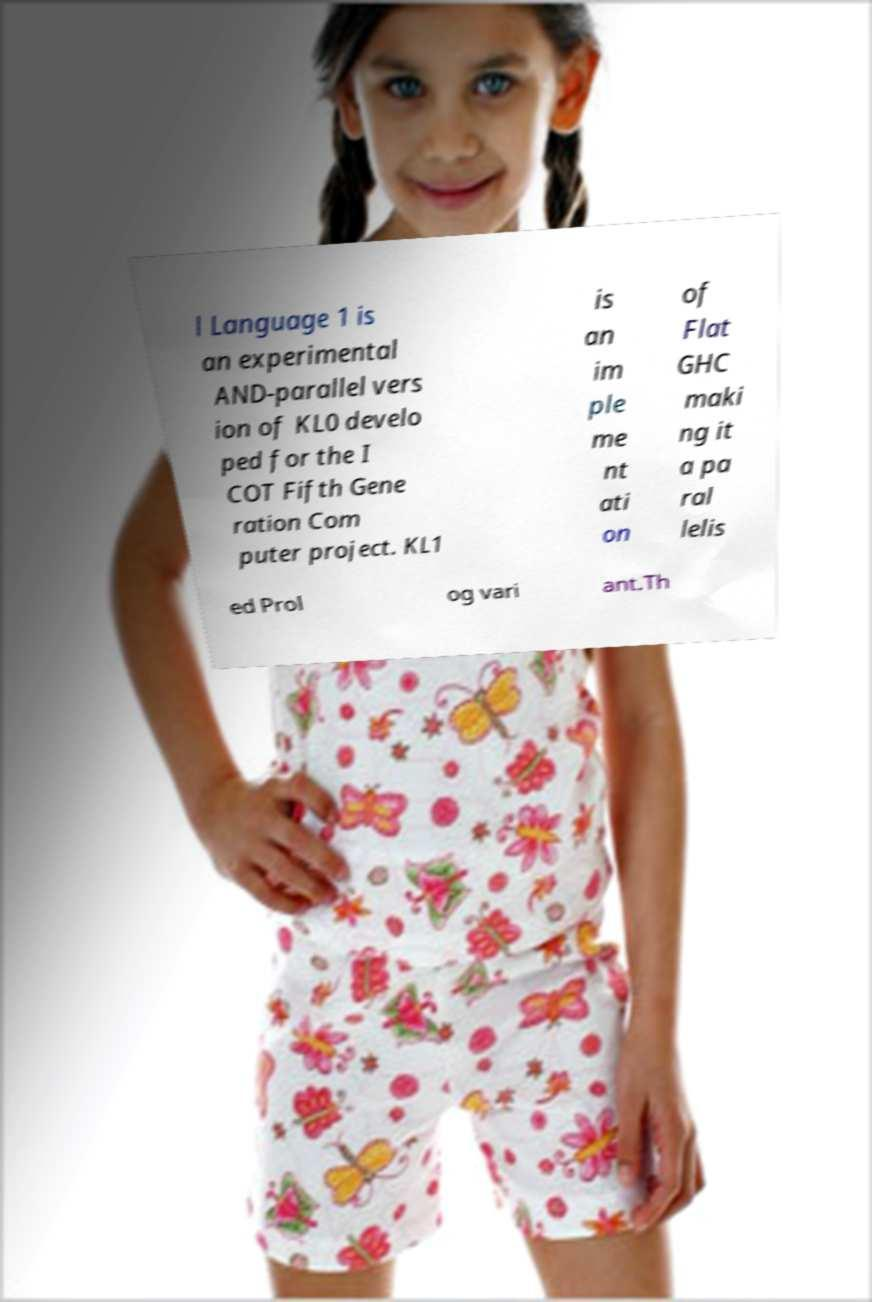What messages or text are displayed in this image? I need them in a readable, typed format. l Language 1 is an experimental AND-parallel vers ion of KL0 develo ped for the I COT Fifth Gene ration Com puter project. KL1 is an im ple me nt ati on of Flat GHC maki ng it a pa ral lelis ed Prol og vari ant.Th 